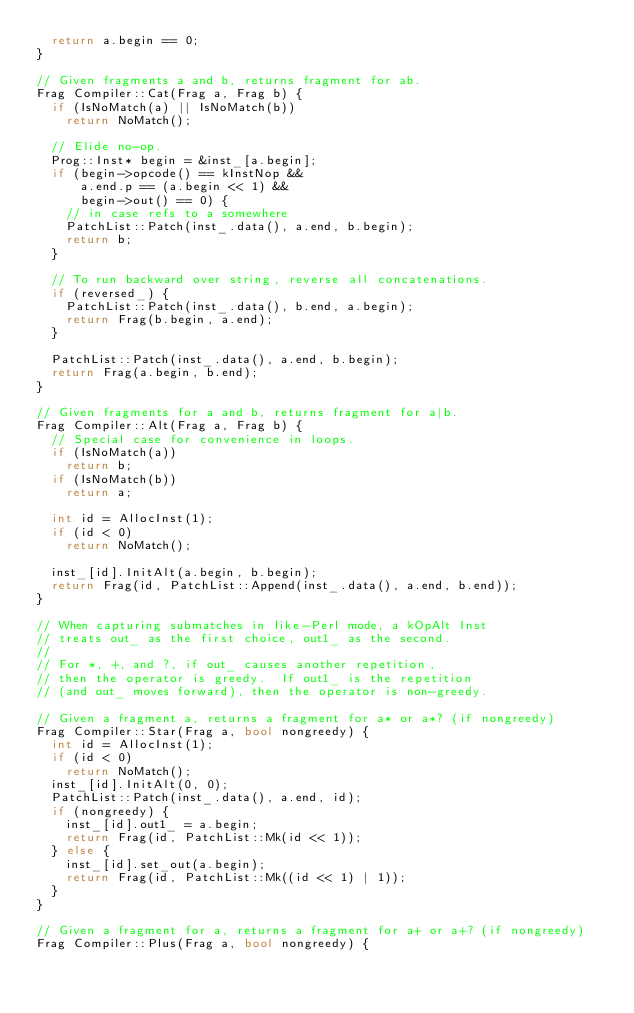Convert code to text. <code><loc_0><loc_0><loc_500><loc_500><_C++_>  return a.begin == 0;
}

// Given fragments a and b, returns fragment for ab.
Frag Compiler::Cat(Frag a, Frag b) {
  if (IsNoMatch(a) || IsNoMatch(b))
    return NoMatch();

  // Elide no-op.
  Prog::Inst* begin = &inst_[a.begin];
  if (begin->opcode() == kInstNop &&
      a.end.p == (a.begin << 1) &&
      begin->out() == 0) {
    // in case refs to a somewhere
    PatchList::Patch(inst_.data(), a.end, b.begin);
    return b;
  }

  // To run backward over string, reverse all concatenations.
  if (reversed_) {
    PatchList::Patch(inst_.data(), b.end, a.begin);
    return Frag(b.begin, a.end);
  }

  PatchList::Patch(inst_.data(), a.end, b.begin);
  return Frag(a.begin, b.end);
}

// Given fragments for a and b, returns fragment for a|b.
Frag Compiler::Alt(Frag a, Frag b) {
  // Special case for convenience in loops.
  if (IsNoMatch(a))
    return b;
  if (IsNoMatch(b))
    return a;

  int id = AllocInst(1);
  if (id < 0)
    return NoMatch();

  inst_[id].InitAlt(a.begin, b.begin);
  return Frag(id, PatchList::Append(inst_.data(), a.end, b.end));
}

// When capturing submatches in like-Perl mode, a kOpAlt Inst
// treats out_ as the first choice, out1_ as the second.
//
// For *, +, and ?, if out_ causes another repetition,
// then the operator is greedy.  If out1_ is the repetition
// (and out_ moves forward), then the operator is non-greedy.

// Given a fragment a, returns a fragment for a* or a*? (if nongreedy)
Frag Compiler::Star(Frag a, bool nongreedy) {
  int id = AllocInst(1);
  if (id < 0)
    return NoMatch();
  inst_[id].InitAlt(0, 0);
  PatchList::Patch(inst_.data(), a.end, id);
  if (nongreedy) {
    inst_[id].out1_ = a.begin;
    return Frag(id, PatchList::Mk(id << 1));
  } else {
    inst_[id].set_out(a.begin);
    return Frag(id, PatchList::Mk((id << 1) | 1));
  }
}

// Given a fragment for a, returns a fragment for a+ or a+? (if nongreedy)
Frag Compiler::Plus(Frag a, bool nongreedy) {</code> 